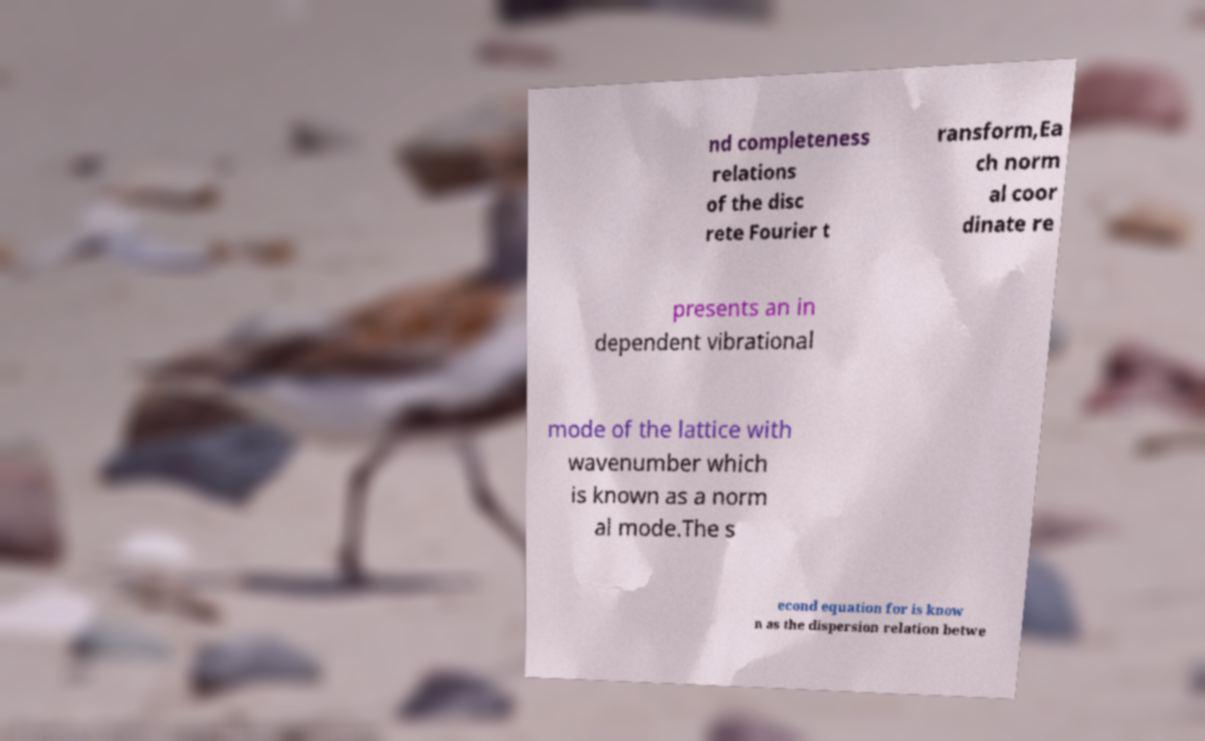I need the written content from this picture converted into text. Can you do that? nd completeness relations of the disc rete Fourier t ransform,Ea ch norm al coor dinate re presents an in dependent vibrational mode of the lattice with wavenumber which is known as a norm al mode.The s econd equation for is know n as the dispersion relation betwe 